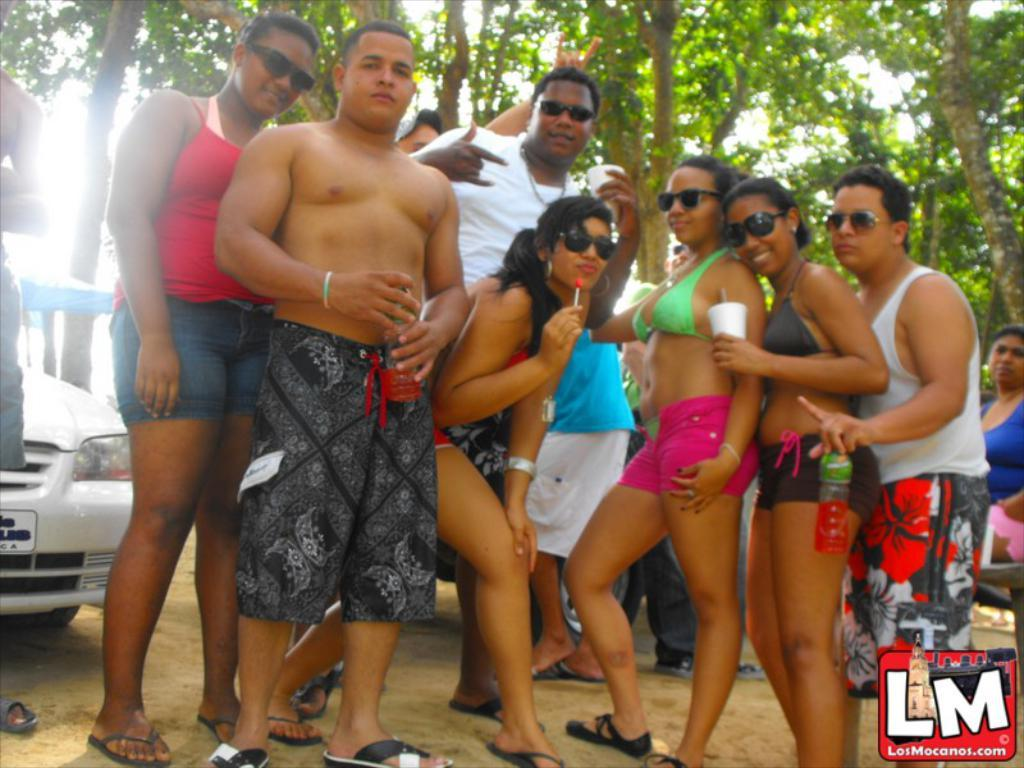What are the people in the image doing? The people in the image are posing for a photo. What can be seen in the background of the image? There is a vehicle and trees visible in the background of the image. What color is the crayon being used by the person in the image? There is no crayon present in the image. What is the tendency of the edge of the vehicle in the image? The image does not provide information about the edge of the vehicle or any tendencies it might have. 